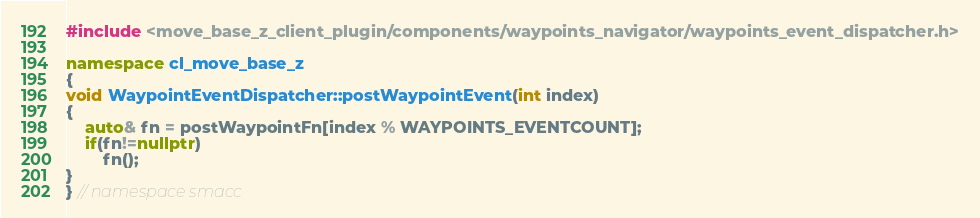Convert code to text. <code><loc_0><loc_0><loc_500><loc_500><_C++_>#include <move_base_z_client_plugin/components/waypoints_navigator/waypoints_event_dispatcher.h>

namespace cl_move_base_z
{
void WaypointEventDispatcher::postWaypointEvent(int index)
{
    auto& fn = postWaypointFn[index % WAYPOINTS_EVENTCOUNT];
    if(fn!=nullptr)
        fn();
}
} // namespace smacc</code> 